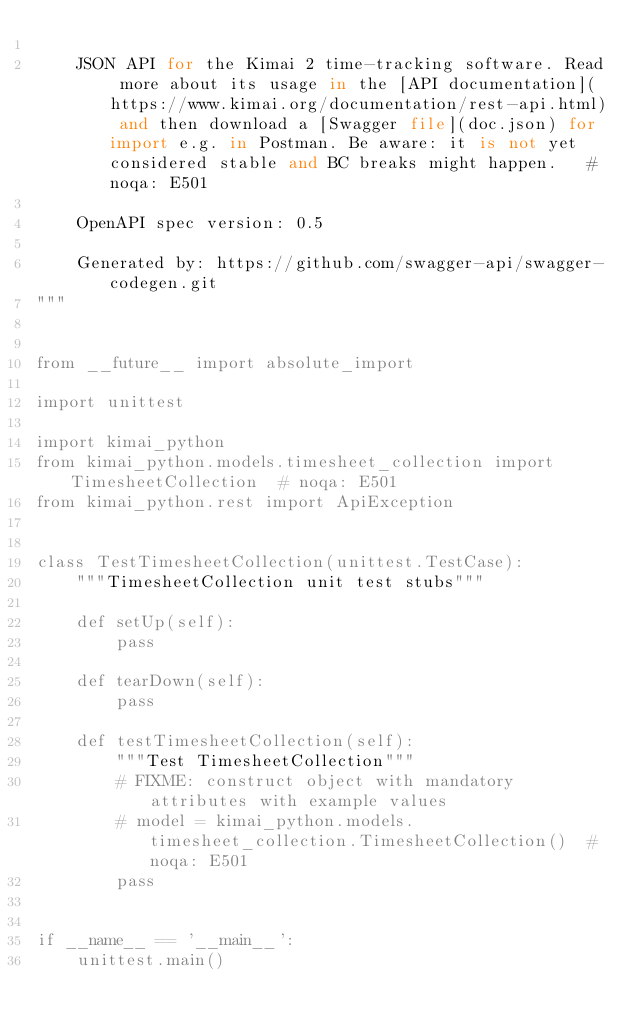<code> <loc_0><loc_0><loc_500><loc_500><_Python_>
    JSON API for the Kimai 2 time-tracking software. Read more about its usage in the [API documentation](https://www.kimai.org/documentation/rest-api.html) and then download a [Swagger file](doc.json) for import e.g. in Postman. Be aware: it is not yet considered stable and BC breaks might happen.   # noqa: E501

    OpenAPI spec version: 0.5
    
    Generated by: https://github.com/swagger-api/swagger-codegen.git
"""


from __future__ import absolute_import

import unittest

import kimai_python
from kimai_python.models.timesheet_collection import TimesheetCollection  # noqa: E501
from kimai_python.rest import ApiException


class TestTimesheetCollection(unittest.TestCase):
    """TimesheetCollection unit test stubs"""

    def setUp(self):
        pass

    def tearDown(self):
        pass

    def testTimesheetCollection(self):
        """Test TimesheetCollection"""
        # FIXME: construct object with mandatory attributes with example values
        # model = kimai_python.models.timesheet_collection.TimesheetCollection()  # noqa: E501
        pass


if __name__ == '__main__':
    unittest.main()
</code> 